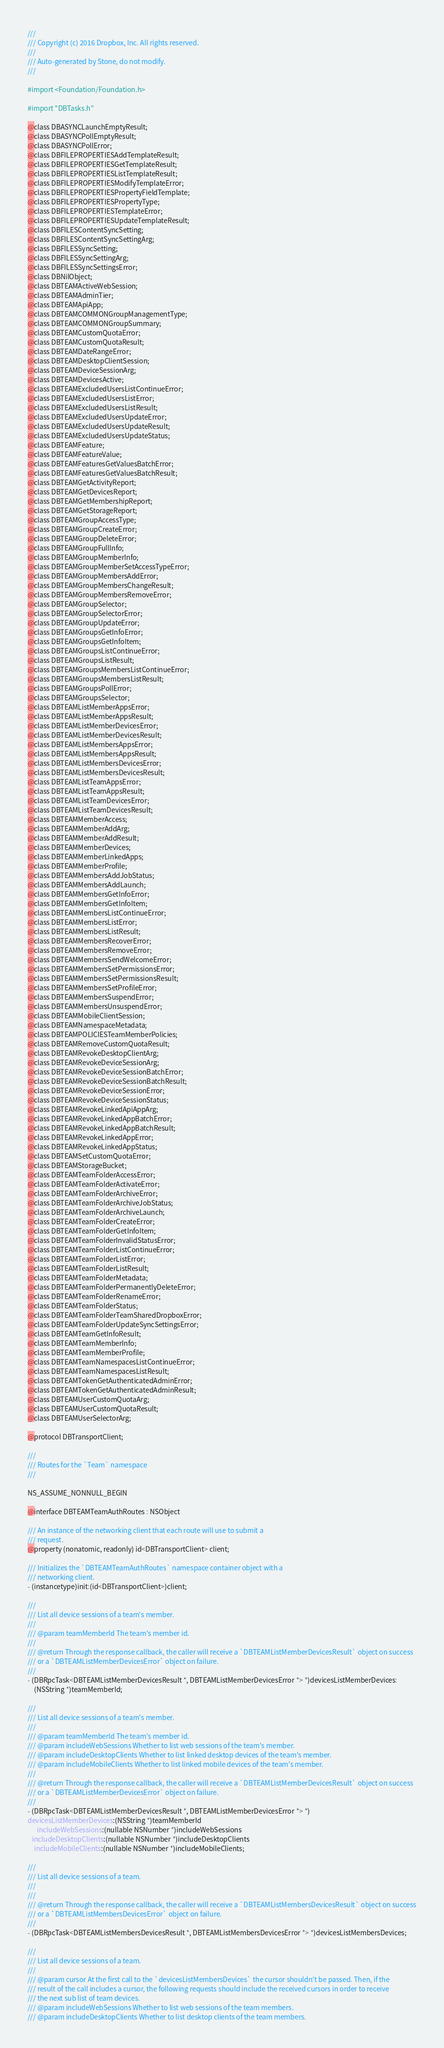<code> <loc_0><loc_0><loc_500><loc_500><_C_>///
/// Copyright (c) 2016 Dropbox, Inc. All rights reserved.
///
/// Auto-generated by Stone, do not modify.
///

#import <Foundation/Foundation.h>

#import "DBTasks.h"

@class DBASYNCLaunchEmptyResult;
@class DBASYNCPollEmptyResult;
@class DBASYNCPollError;
@class DBFILEPROPERTIESAddTemplateResult;
@class DBFILEPROPERTIESGetTemplateResult;
@class DBFILEPROPERTIESListTemplateResult;
@class DBFILEPROPERTIESModifyTemplateError;
@class DBFILEPROPERTIESPropertyFieldTemplate;
@class DBFILEPROPERTIESPropertyType;
@class DBFILEPROPERTIESTemplateError;
@class DBFILEPROPERTIESUpdateTemplateResult;
@class DBFILESContentSyncSetting;
@class DBFILESContentSyncSettingArg;
@class DBFILESSyncSetting;
@class DBFILESSyncSettingArg;
@class DBFILESSyncSettingsError;
@class DBNilObject;
@class DBTEAMActiveWebSession;
@class DBTEAMAdminTier;
@class DBTEAMApiApp;
@class DBTEAMCOMMONGroupManagementType;
@class DBTEAMCOMMONGroupSummary;
@class DBTEAMCustomQuotaError;
@class DBTEAMCustomQuotaResult;
@class DBTEAMDateRangeError;
@class DBTEAMDesktopClientSession;
@class DBTEAMDeviceSessionArg;
@class DBTEAMDevicesActive;
@class DBTEAMExcludedUsersListContinueError;
@class DBTEAMExcludedUsersListError;
@class DBTEAMExcludedUsersListResult;
@class DBTEAMExcludedUsersUpdateError;
@class DBTEAMExcludedUsersUpdateResult;
@class DBTEAMExcludedUsersUpdateStatus;
@class DBTEAMFeature;
@class DBTEAMFeatureValue;
@class DBTEAMFeaturesGetValuesBatchError;
@class DBTEAMFeaturesGetValuesBatchResult;
@class DBTEAMGetActivityReport;
@class DBTEAMGetDevicesReport;
@class DBTEAMGetMembershipReport;
@class DBTEAMGetStorageReport;
@class DBTEAMGroupAccessType;
@class DBTEAMGroupCreateError;
@class DBTEAMGroupDeleteError;
@class DBTEAMGroupFullInfo;
@class DBTEAMGroupMemberInfo;
@class DBTEAMGroupMemberSetAccessTypeError;
@class DBTEAMGroupMembersAddError;
@class DBTEAMGroupMembersChangeResult;
@class DBTEAMGroupMembersRemoveError;
@class DBTEAMGroupSelector;
@class DBTEAMGroupSelectorError;
@class DBTEAMGroupUpdateError;
@class DBTEAMGroupsGetInfoError;
@class DBTEAMGroupsGetInfoItem;
@class DBTEAMGroupsListContinueError;
@class DBTEAMGroupsListResult;
@class DBTEAMGroupsMembersListContinueError;
@class DBTEAMGroupsMembersListResult;
@class DBTEAMGroupsPollError;
@class DBTEAMGroupsSelector;
@class DBTEAMListMemberAppsError;
@class DBTEAMListMemberAppsResult;
@class DBTEAMListMemberDevicesError;
@class DBTEAMListMemberDevicesResult;
@class DBTEAMListMembersAppsError;
@class DBTEAMListMembersAppsResult;
@class DBTEAMListMembersDevicesError;
@class DBTEAMListMembersDevicesResult;
@class DBTEAMListTeamAppsError;
@class DBTEAMListTeamAppsResult;
@class DBTEAMListTeamDevicesError;
@class DBTEAMListTeamDevicesResult;
@class DBTEAMMemberAccess;
@class DBTEAMMemberAddArg;
@class DBTEAMMemberAddResult;
@class DBTEAMMemberDevices;
@class DBTEAMMemberLinkedApps;
@class DBTEAMMemberProfile;
@class DBTEAMMembersAddJobStatus;
@class DBTEAMMembersAddLaunch;
@class DBTEAMMembersGetInfoError;
@class DBTEAMMembersGetInfoItem;
@class DBTEAMMembersListContinueError;
@class DBTEAMMembersListError;
@class DBTEAMMembersListResult;
@class DBTEAMMembersRecoverError;
@class DBTEAMMembersRemoveError;
@class DBTEAMMembersSendWelcomeError;
@class DBTEAMMembersSetPermissionsError;
@class DBTEAMMembersSetPermissionsResult;
@class DBTEAMMembersSetProfileError;
@class DBTEAMMembersSuspendError;
@class DBTEAMMembersUnsuspendError;
@class DBTEAMMobileClientSession;
@class DBTEAMNamespaceMetadata;
@class DBTEAMPOLICIESTeamMemberPolicies;
@class DBTEAMRemoveCustomQuotaResult;
@class DBTEAMRevokeDesktopClientArg;
@class DBTEAMRevokeDeviceSessionArg;
@class DBTEAMRevokeDeviceSessionBatchError;
@class DBTEAMRevokeDeviceSessionBatchResult;
@class DBTEAMRevokeDeviceSessionError;
@class DBTEAMRevokeDeviceSessionStatus;
@class DBTEAMRevokeLinkedApiAppArg;
@class DBTEAMRevokeLinkedAppBatchError;
@class DBTEAMRevokeLinkedAppBatchResult;
@class DBTEAMRevokeLinkedAppError;
@class DBTEAMRevokeLinkedAppStatus;
@class DBTEAMSetCustomQuotaError;
@class DBTEAMStorageBucket;
@class DBTEAMTeamFolderAccessError;
@class DBTEAMTeamFolderActivateError;
@class DBTEAMTeamFolderArchiveError;
@class DBTEAMTeamFolderArchiveJobStatus;
@class DBTEAMTeamFolderArchiveLaunch;
@class DBTEAMTeamFolderCreateError;
@class DBTEAMTeamFolderGetInfoItem;
@class DBTEAMTeamFolderInvalidStatusError;
@class DBTEAMTeamFolderListContinueError;
@class DBTEAMTeamFolderListError;
@class DBTEAMTeamFolderListResult;
@class DBTEAMTeamFolderMetadata;
@class DBTEAMTeamFolderPermanentlyDeleteError;
@class DBTEAMTeamFolderRenameError;
@class DBTEAMTeamFolderStatus;
@class DBTEAMTeamFolderTeamSharedDropboxError;
@class DBTEAMTeamFolderUpdateSyncSettingsError;
@class DBTEAMTeamGetInfoResult;
@class DBTEAMTeamMemberInfo;
@class DBTEAMTeamMemberProfile;
@class DBTEAMTeamNamespacesListContinueError;
@class DBTEAMTeamNamespacesListResult;
@class DBTEAMTokenGetAuthenticatedAdminError;
@class DBTEAMTokenGetAuthenticatedAdminResult;
@class DBTEAMUserCustomQuotaArg;
@class DBTEAMUserCustomQuotaResult;
@class DBTEAMUserSelectorArg;

@protocol DBTransportClient;

///
/// Routes for the `Team` namespace
///

NS_ASSUME_NONNULL_BEGIN

@interface DBTEAMTeamAuthRoutes : NSObject

/// An instance of the networking client that each route will use to submit a
/// request.
@property (nonatomic, readonly) id<DBTransportClient> client;

/// Initializes the `DBTEAMTeamAuthRoutes` namespace container object with a
/// networking client.
- (instancetype)init:(id<DBTransportClient>)client;

///
/// List all device sessions of a team's member.
///
/// @param teamMemberId The team's member id.
///
/// @return Through the response callback, the caller will receive a `DBTEAMListMemberDevicesResult` object on success
/// or a `DBTEAMListMemberDevicesError` object on failure.
///
- (DBRpcTask<DBTEAMListMemberDevicesResult *, DBTEAMListMemberDevicesError *> *)devicesListMemberDevices:
    (NSString *)teamMemberId;

///
/// List all device sessions of a team's member.
///
/// @param teamMemberId The team's member id.
/// @param includeWebSessions Whether to list web sessions of the team's member.
/// @param includeDesktopClients Whether to list linked desktop devices of the team's member.
/// @param includeMobileClients Whether to list linked mobile devices of the team's member.
///
/// @return Through the response callback, the caller will receive a `DBTEAMListMemberDevicesResult` object on success
/// or a `DBTEAMListMemberDevicesError` object on failure.
///
- (DBRpcTask<DBTEAMListMemberDevicesResult *, DBTEAMListMemberDevicesError *> *)
devicesListMemberDevices:(NSString *)teamMemberId
      includeWebSessions:(nullable NSNumber *)includeWebSessions
   includeDesktopClients:(nullable NSNumber *)includeDesktopClients
    includeMobileClients:(nullable NSNumber *)includeMobileClients;

///
/// List all device sessions of a team.
///
///
/// @return Through the response callback, the caller will receive a `DBTEAMListMembersDevicesResult` object on success
/// or a `DBTEAMListMembersDevicesError` object on failure.
///
- (DBRpcTask<DBTEAMListMembersDevicesResult *, DBTEAMListMembersDevicesError *> *)devicesListMembersDevices;

///
/// List all device sessions of a team.
///
/// @param cursor At the first call to the `devicesListMembersDevices` the cursor shouldn't be passed. Then, if the
/// result of the call includes a cursor, the following requests should include the received cursors in order to receive
/// the next sub list of team devices.
/// @param includeWebSessions Whether to list web sessions of the team members.
/// @param includeDesktopClients Whether to list desktop clients of the team members.</code> 